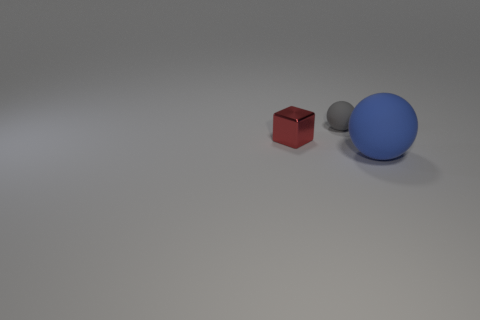Which object in the image seems to reflect the most light? The large blue sphere seems to have a high reflectivity, indicated by the bright highlight and the more defined reflection on its surface. 